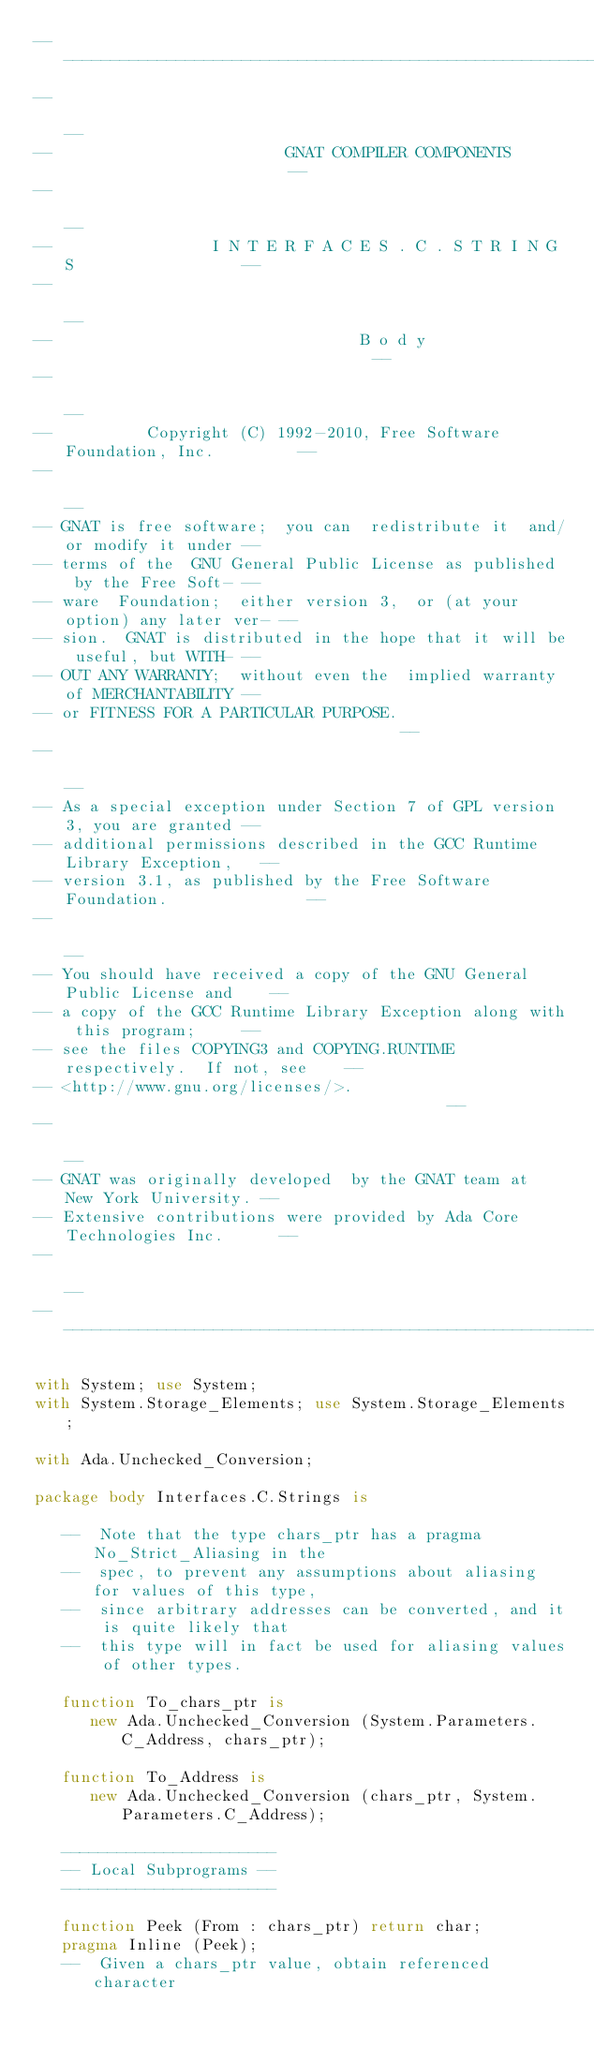<code> <loc_0><loc_0><loc_500><loc_500><_Ada_>------------------------------------------------------------------------------
--                                                                          --
--                         GNAT COMPILER COMPONENTS                         --
--                                                                          --
--                 I N T E R F A C E S . C . S T R I N G S                  --
--                                                                          --
--                                 B o d y                                  --
--                                                                          --
--          Copyright (C) 1992-2010, Free Software Foundation, Inc.         --
--                                                                          --
-- GNAT is free software;  you can  redistribute it  and/or modify it under --
-- terms of the  GNU General Public License as published  by the Free Soft- --
-- ware  Foundation;  either version 3,  or (at your option) any later ver- --
-- sion.  GNAT is distributed in the hope that it will be useful, but WITH- --
-- OUT ANY WARRANTY;  without even the  implied warranty of MERCHANTABILITY --
-- or FITNESS FOR A PARTICULAR PURPOSE.                                     --
--                                                                          --
-- As a special exception under Section 7 of GPL version 3, you are granted --
-- additional permissions described in the GCC Runtime Library Exception,   --
-- version 3.1, as published by the Free Software Foundation.               --
--                                                                          --
-- You should have received a copy of the GNU General Public License and    --
-- a copy of the GCC Runtime Library Exception along with this program;     --
-- see the files COPYING3 and COPYING.RUNTIME respectively.  If not, see    --
-- <http://www.gnu.org/licenses/>.                                          --
--                                                                          --
-- GNAT was originally developed  by the GNAT team at  New York University. --
-- Extensive contributions were provided by Ada Core Technologies Inc.      --
--                                                                          --
------------------------------------------------------------------------------

with System; use System;
with System.Storage_Elements; use System.Storage_Elements;

with Ada.Unchecked_Conversion;

package body Interfaces.C.Strings is

   --  Note that the type chars_ptr has a pragma No_Strict_Aliasing in the
   --  spec, to prevent any assumptions about aliasing for values of this type,
   --  since arbitrary addresses can be converted, and it is quite likely that
   --  this type will in fact be used for aliasing values of other types.

   function To_chars_ptr is
      new Ada.Unchecked_Conversion (System.Parameters.C_Address, chars_ptr);

   function To_Address is
      new Ada.Unchecked_Conversion (chars_ptr, System.Parameters.C_Address);

   -----------------------
   -- Local Subprograms --
   -----------------------

   function Peek (From : chars_ptr) return char;
   pragma Inline (Peek);
   --  Given a chars_ptr value, obtain referenced character
</code> 